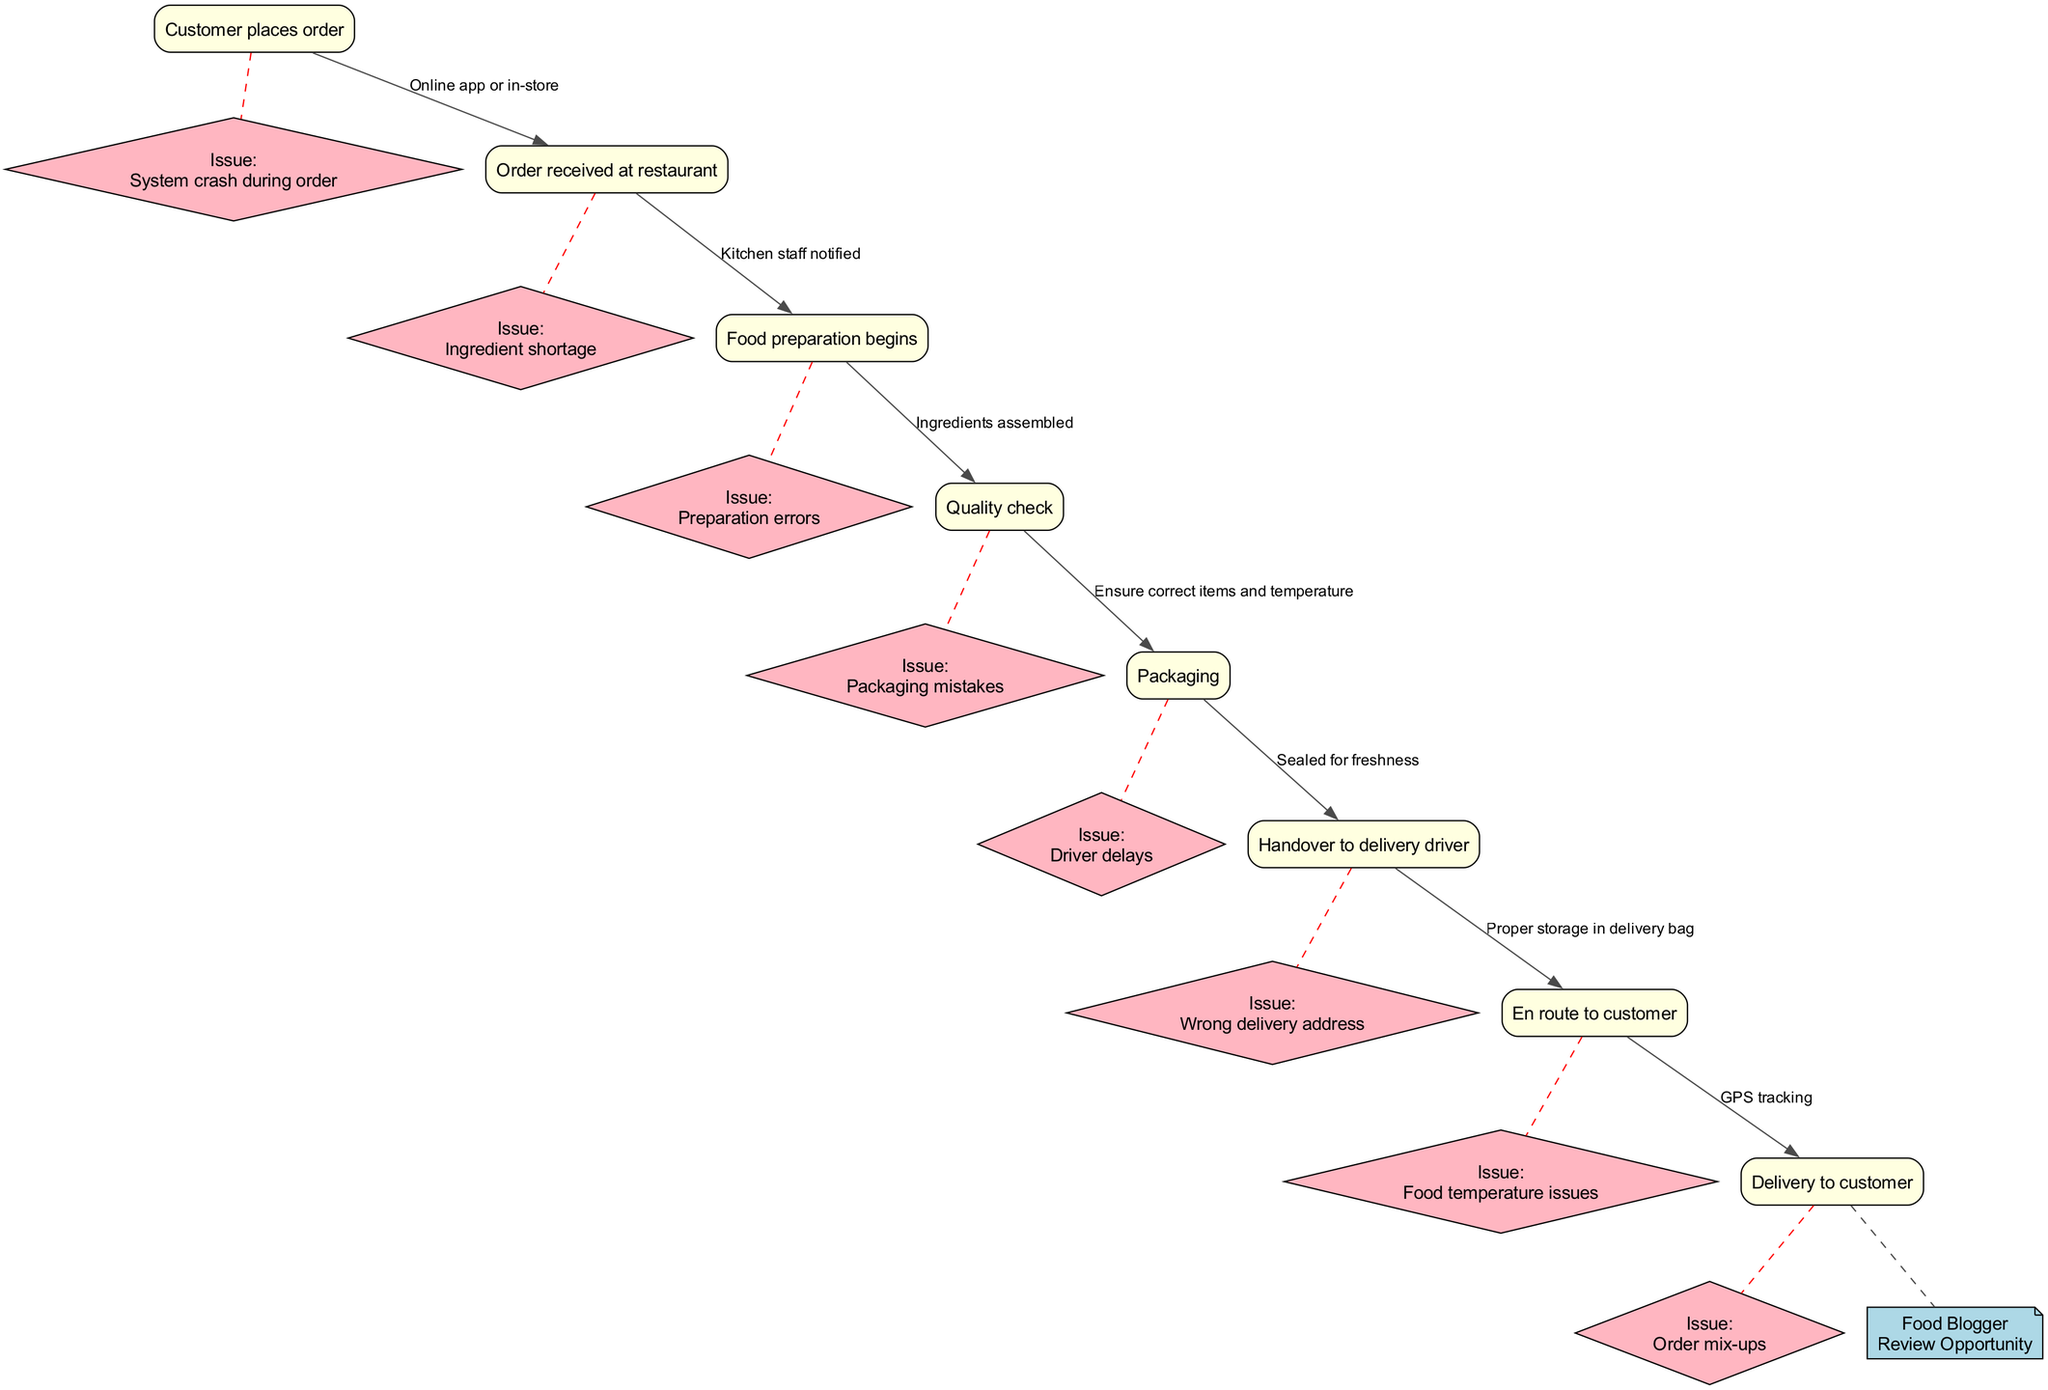What is the first node in the flow chart? The first node is "Customer places order," which indicates the starting point of the fast-food item journey.
Answer: Customer places order How many nodes are there in total? The flow chart contains 8 nodes representing different stages of the fast-food item journey.
Answer: 8 What relays the food preparation begins to the quality check? The edge between "Food preparation begins" and "Quality check" represents the action taken, which is ensuring the quality of the food being prepared.
Answer: Ensure correct items and temperature What potential issue is associated with food preparation? "Preparation errors," which could arise during the cooking process or assembly of the fast-food item.
Answer: Preparation errors What is the last node for the fast-food delivery process? The final node is "Delivery to customer," marking the conclusion of the item’s journey.
Answer: Delivery to customer How many potential issues are listed in the flow chart? There are 8 potential issues identified that could arise during the fast-food delivery process.
Answer: 8 What happens after packaging in the flow chart? The next step following the "Packaging" node is "Handover to delivery driver," indicating the transition from packing to delivery.
Answer: Handover to delivery driver What type of opportunity does the flow chart provide at the end? The flow chart allows for a "Food bloggers' review opportunity" which indicates a point for customers to provide feedback.
Answer: Food bloggers' review opportunity Which node is directly linked to "Driver delays"? "Handover to delivery driver" is the node directly linked to "Driver delays," highlighting potential issues during delivery.
Answer: Handover to delivery driver 